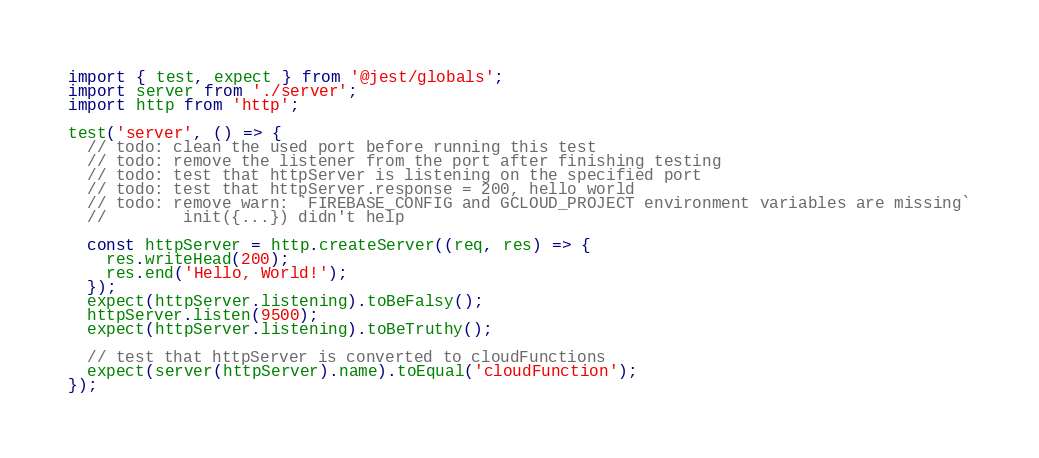Convert code to text. <code><loc_0><loc_0><loc_500><loc_500><_TypeScript_>import { test, expect } from '@jest/globals';
import server from './server';
import http from 'http';

test('server', () => {
  // todo: clean the used port before running this test
  // todo: remove the listener from the port after finishing testing
  // todo: test that httpServer is listening on the specified port
  // todo: test that httpServer.response = 200, hello world
  // todo: remove warn: `FIREBASE_CONFIG and GCLOUD_PROJECT environment variables are missing`
  //        init({...}) didn't help

  const httpServer = http.createServer((req, res) => {
    res.writeHead(200);
    res.end('Hello, World!');
  });
  expect(httpServer.listening).toBeFalsy();
  httpServer.listen(9500);
  expect(httpServer.listening).toBeTruthy();

  // test that httpServer is converted to cloudFunctions
  expect(server(httpServer).name).toEqual('cloudFunction');
});
</code> 